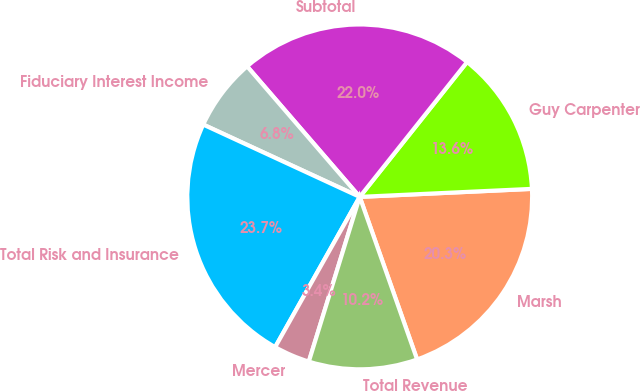<chart> <loc_0><loc_0><loc_500><loc_500><pie_chart><fcel>Marsh<fcel>Guy Carpenter<fcel>Subtotal<fcel>Fiduciary Interest Income<fcel>Total Risk and Insurance<fcel>Mercer<fcel>Total Revenue<nl><fcel>20.34%<fcel>13.56%<fcel>22.03%<fcel>6.78%<fcel>23.73%<fcel>3.39%<fcel>10.17%<nl></chart> 